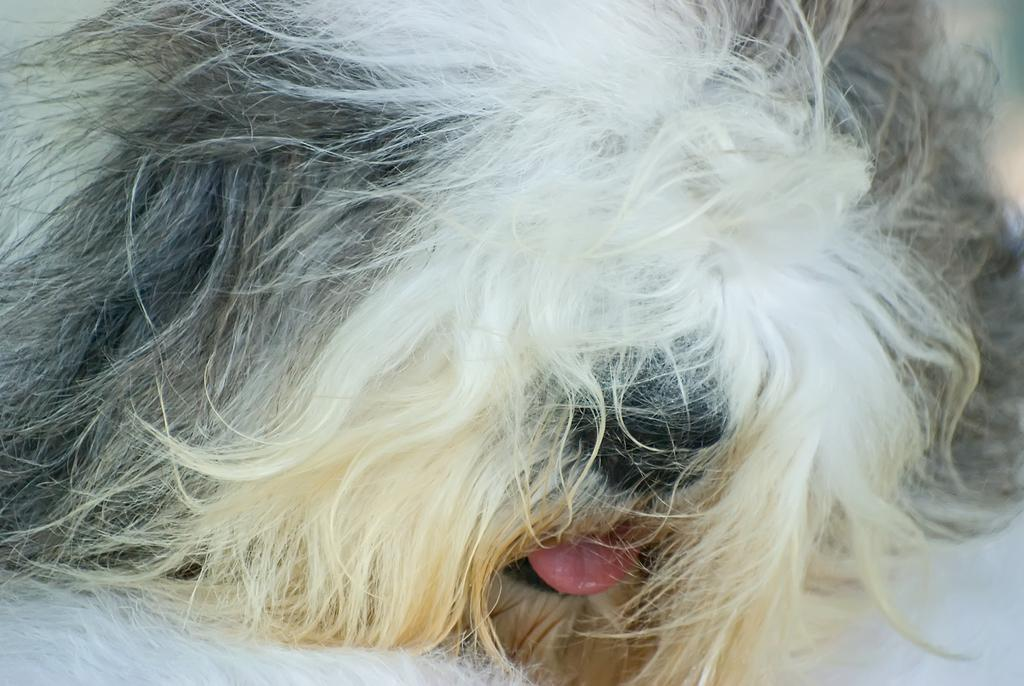What animal is present in the image? There is a dog in the image. What is the dog doing in the image? The dog is lying on the floor. In which direction is the dog facing in the image? The provided facts do not specify the direction the dog is facing in the image. What type of curve can be seen in the dog's tail in the image? The provided facts do not mention the dog's tail or any curves in the image. 